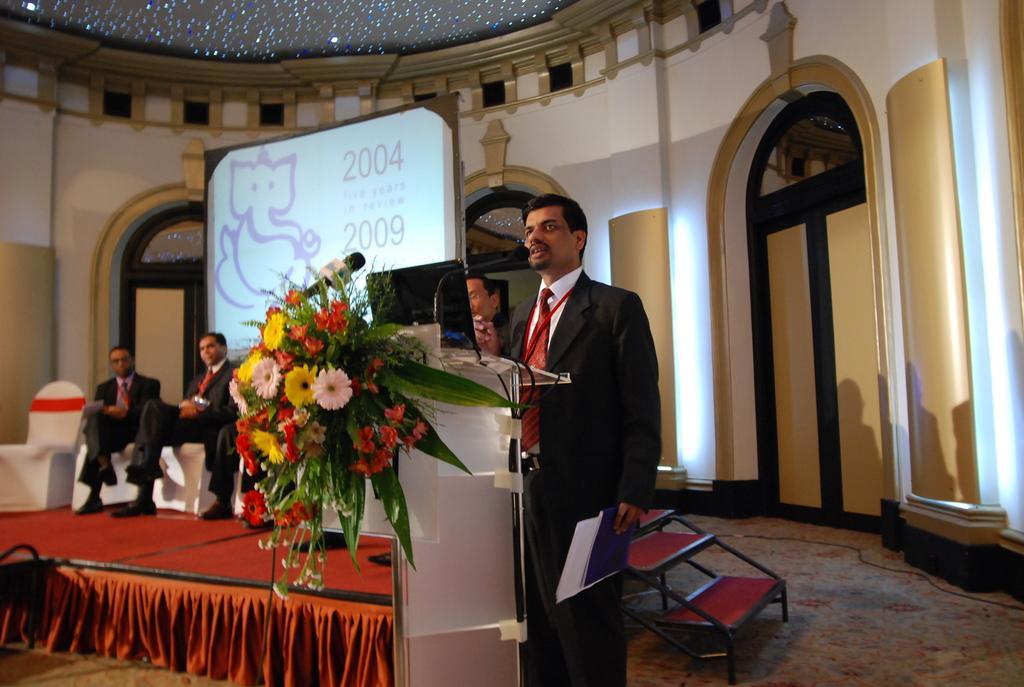How would you summarize this image in a sentence or two? This is the inside view of a building. Here we can see a person standing in front of mike and holding papers. This is the beautiful flower bouquet. Here few people are sitting on the chair. This is the screen. And on the background we can see the wall with the combination of gold and white colour. 